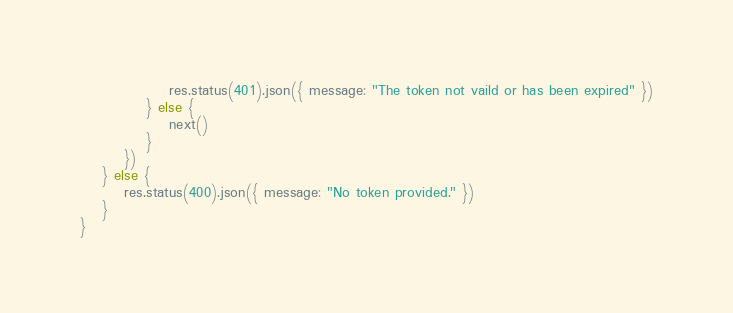<code> <loc_0><loc_0><loc_500><loc_500><_JavaScript_>                res.status(401).json({ message: "The token not vaild or has been expired" })
            } else {
                next()
            }
        })
    } else {
        res.status(400).json({ message: "No token provided." })
    }
}</code> 